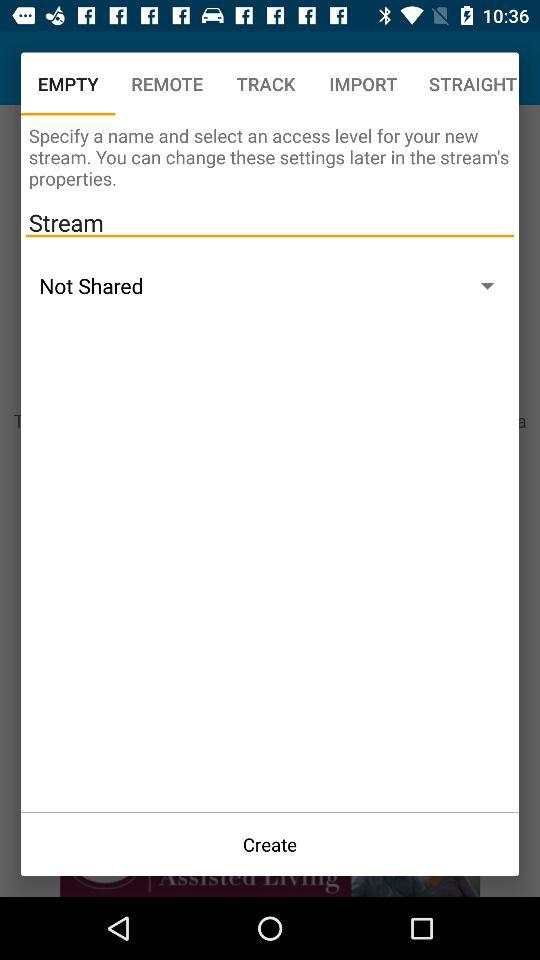What is the description of "REMOTE"?
When the provided information is insufficient, respond with <no answer>. <no answer> 